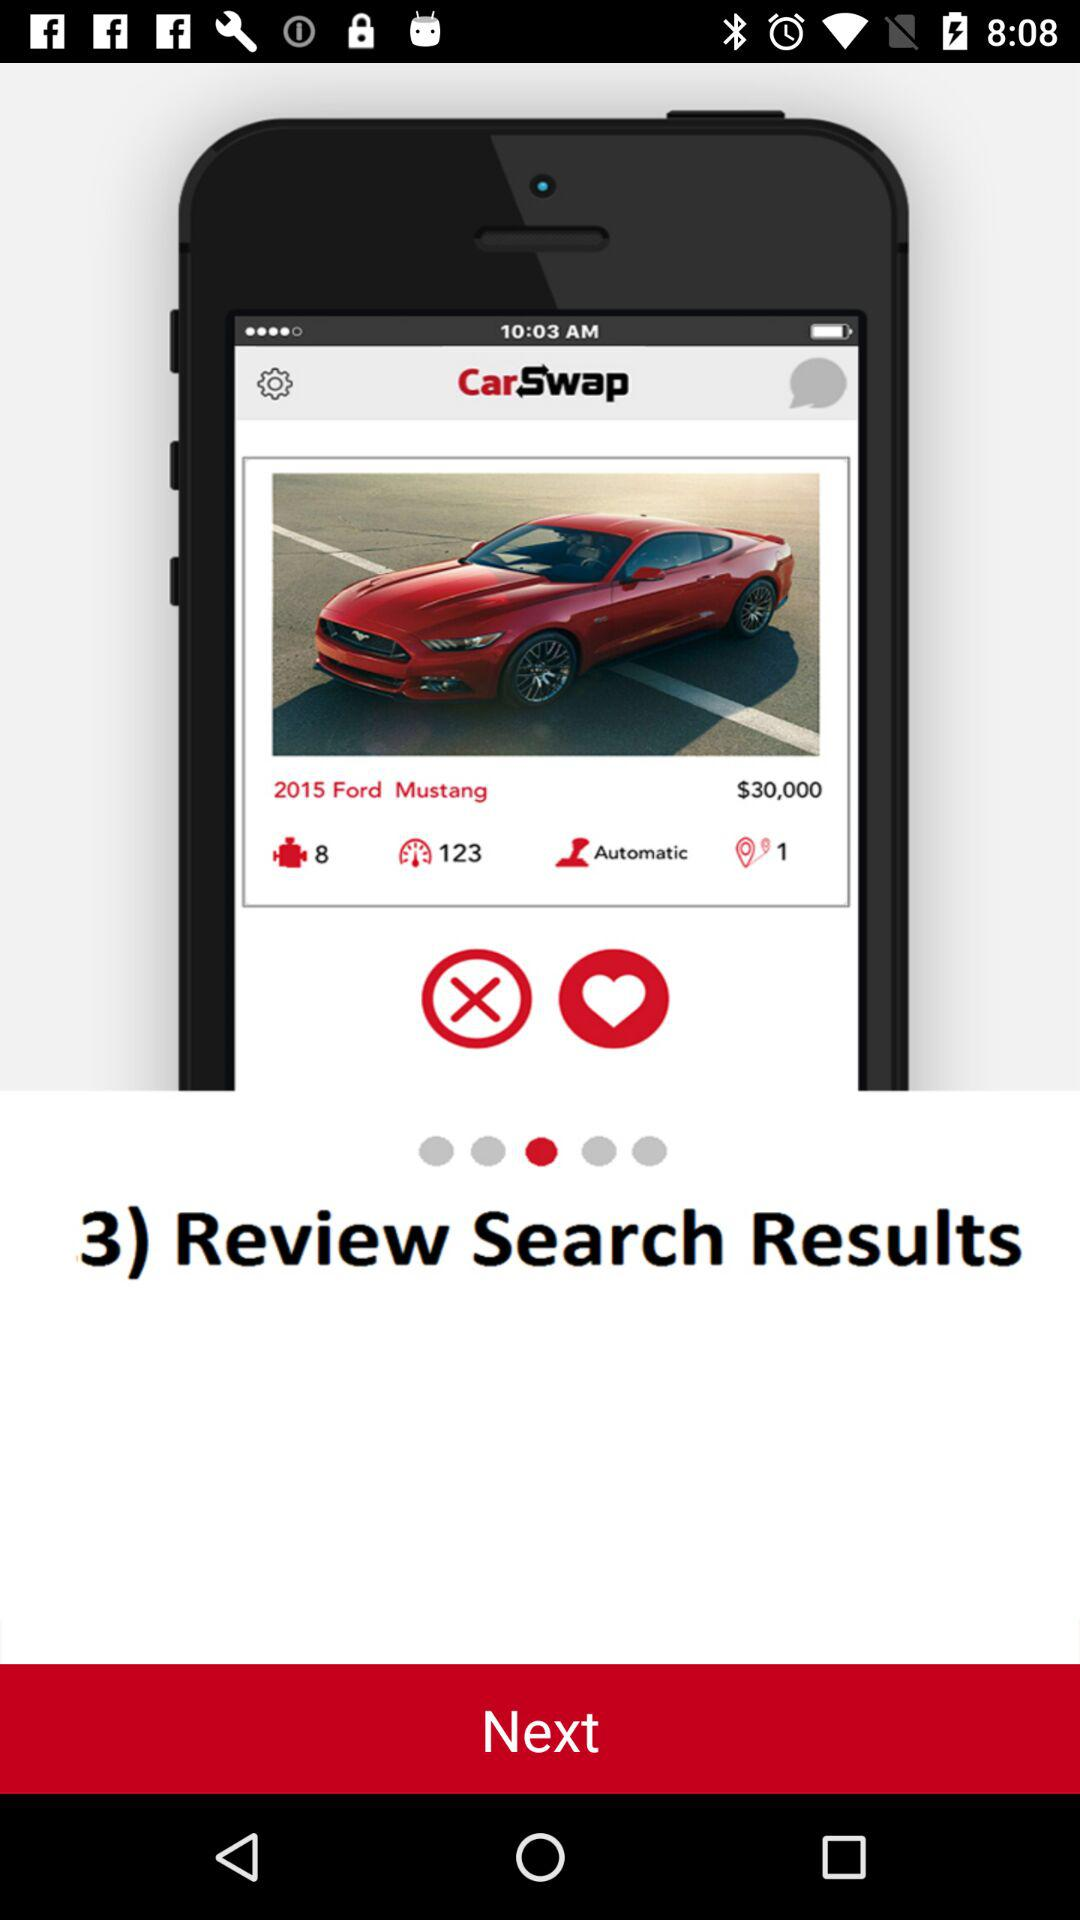What is the application name? The application name is "CarSwap". 